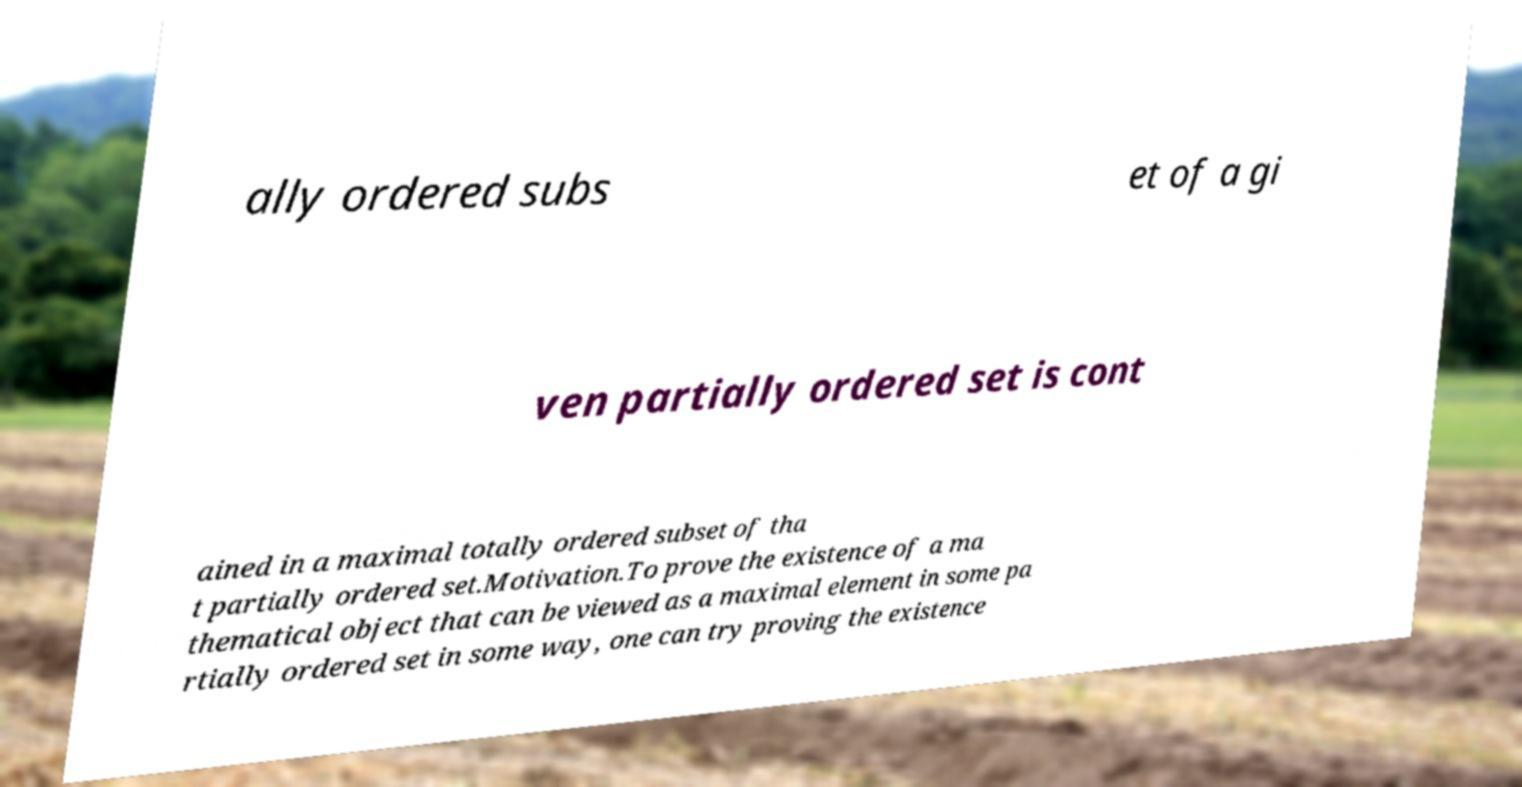Please identify and transcribe the text found in this image. ally ordered subs et of a gi ven partially ordered set is cont ained in a maximal totally ordered subset of tha t partially ordered set.Motivation.To prove the existence of a ma thematical object that can be viewed as a maximal element in some pa rtially ordered set in some way, one can try proving the existence 